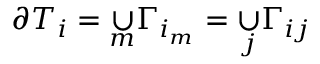<formula> <loc_0><loc_0><loc_500><loc_500>\partial T _ { i } = \underset { m } { \cup } \Gamma _ { i _ { m } } = \underset { j } { \cup } \Gamma _ { i j }</formula> 